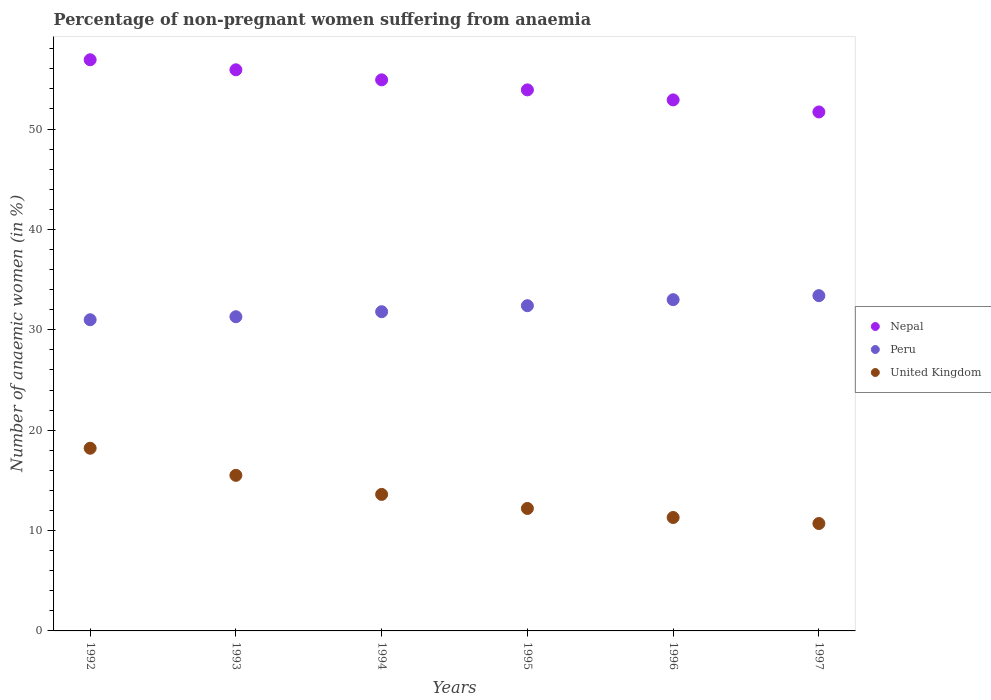What is the percentage of non-pregnant women suffering from anaemia in Peru in 1993?
Provide a short and direct response. 31.3. Across all years, what is the minimum percentage of non-pregnant women suffering from anaemia in Nepal?
Your response must be concise. 51.7. In which year was the percentage of non-pregnant women suffering from anaemia in Nepal minimum?
Offer a terse response. 1997. What is the total percentage of non-pregnant women suffering from anaemia in United Kingdom in the graph?
Your answer should be compact. 81.5. What is the difference between the percentage of non-pregnant women suffering from anaemia in United Kingdom in 1995 and that in 1997?
Your response must be concise. 1.5. What is the difference between the percentage of non-pregnant women suffering from anaemia in Peru in 1994 and the percentage of non-pregnant women suffering from anaemia in Nepal in 1996?
Give a very brief answer. -21.1. What is the average percentage of non-pregnant women suffering from anaemia in Nepal per year?
Ensure brevity in your answer.  54.37. In the year 1993, what is the difference between the percentage of non-pregnant women suffering from anaemia in United Kingdom and percentage of non-pregnant women suffering from anaemia in Nepal?
Your response must be concise. -40.4. What is the ratio of the percentage of non-pregnant women suffering from anaemia in Peru in 1996 to that in 1997?
Keep it short and to the point. 0.99. Is the difference between the percentage of non-pregnant women suffering from anaemia in United Kingdom in 1993 and 1997 greater than the difference between the percentage of non-pregnant women suffering from anaemia in Nepal in 1993 and 1997?
Provide a short and direct response. Yes. What is the difference between the highest and the second highest percentage of non-pregnant women suffering from anaemia in United Kingdom?
Offer a terse response. 2.7. Is the sum of the percentage of non-pregnant women suffering from anaemia in Nepal in 1993 and 1996 greater than the maximum percentage of non-pregnant women suffering from anaemia in United Kingdom across all years?
Provide a succinct answer. Yes. What is the difference between two consecutive major ticks on the Y-axis?
Make the answer very short. 10. Are the values on the major ticks of Y-axis written in scientific E-notation?
Offer a very short reply. No. How many legend labels are there?
Your answer should be very brief. 3. How are the legend labels stacked?
Provide a short and direct response. Vertical. What is the title of the graph?
Ensure brevity in your answer.  Percentage of non-pregnant women suffering from anaemia. What is the label or title of the X-axis?
Give a very brief answer. Years. What is the label or title of the Y-axis?
Keep it short and to the point. Number of anaemic women (in %). What is the Number of anaemic women (in %) in Nepal in 1992?
Give a very brief answer. 56.9. What is the Number of anaemic women (in %) in Nepal in 1993?
Provide a succinct answer. 55.9. What is the Number of anaemic women (in %) in Peru in 1993?
Offer a terse response. 31.3. What is the Number of anaemic women (in %) of Nepal in 1994?
Your answer should be very brief. 54.9. What is the Number of anaemic women (in %) in Peru in 1994?
Ensure brevity in your answer.  31.8. What is the Number of anaemic women (in %) of United Kingdom in 1994?
Your answer should be compact. 13.6. What is the Number of anaemic women (in %) of Nepal in 1995?
Give a very brief answer. 53.9. What is the Number of anaemic women (in %) in Peru in 1995?
Your answer should be compact. 32.4. What is the Number of anaemic women (in %) in Nepal in 1996?
Provide a succinct answer. 52.9. What is the Number of anaemic women (in %) of Nepal in 1997?
Offer a very short reply. 51.7. What is the Number of anaemic women (in %) in Peru in 1997?
Give a very brief answer. 33.4. What is the Number of anaemic women (in %) in United Kingdom in 1997?
Your response must be concise. 10.7. Across all years, what is the maximum Number of anaemic women (in %) in Nepal?
Keep it short and to the point. 56.9. Across all years, what is the maximum Number of anaemic women (in %) of Peru?
Your response must be concise. 33.4. Across all years, what is the maximum Number of anaemic women (in %) in United Kingdom?
Keep it short and to the point. 18.2. Across all years, what is the minimum Number of anaemic women (in %) in Nepal?
Make the answer very short. 51.7. Across all years, what is the minimum Number of anaemic women (in %) of United Kingdom?
Ensure brevity in your answer.  10.7. What is the total Number of anaemic women (in %) in Nepal in the graph?
Ensure brevity in your answer.  326.2. What is the total Number of anaemic women (in %) in Peru in the graph?
Ensure brevity in your answer.  192.9. What is the total Number of anaemic women (in %) in United Kingdom in the graph?
Your response must be concise. 81.5. What is the difference between the Number of anaemic women (in %) of United Kingdom in 1992 and that in 1993?
Keep it short and to the point. 2.7. What is the difference between the Number of anaemic women (in %) in Nepal in 1992 and that in 1994?
Make the answer very short. 2. What is the difference between the Number of anaemic women (in %) of Nepal in 1992 and that in 1995?
Offer a terse response. 3. What is the difference between the Number of anaemic women (in %) of United Kingdom in 1992 and that in 1995?
Make the answer very short. 6. What is the difference between the Number of anaemic women (in %) in Nepal in 1992 and that in 1996?
Your answer should be very brief. 4. What is the difference between the Number of anaemic women (in %) of Peru in 1992 and that in 1996?
Your answer should be very brief. -2. What is the difference between the Number of anaemic women (in %) of United Kingdom in 1992 and that in 1996?
Offer a very short reply. 6.9. What is the difference between the Number of anaemic women (in %) in Nepal in 1992 and that in 1997?
Provide a succinct answer. 5.2. What is the difference between the Number of anaemic women (in %) in Nepal in 1993 and that in 1995?
Offer a terse response. 2. What is the difference between the Number of anaemic women (in %) in United Kingdom in 1993 and that in 1995?
Offer a very short reply. 3.3. What is the difference between the Number of anaemic women (in %) in United Kingdom in 1993 and that in 1996?
Your answer should be very brief. 4.2. What is the difference between the Number of anaemic women (in %) of Nepal in 1993 and that in 1997?
Make the answer very short. 4.2. What is the difference between the Number of anaemic women (in %) of Peru in 1993 and that in 1997?
Offer a terse response. -2.1. What is the difference between the Number of anaemic women (in %) in United Kingdom in 1993 and that in 1997?
Make the answer very short. 4.8. What is the difference between the Number of anaemic women (in %) in Nepal in 1994 and that in 1995?
Keep it short and to the point. 1. What is the difference between the Number of anaemic women (in %) in United Kingdom in 1994 and that in 1995?
Offer a very short reply. 1.4. What is the difference between the Number of anaemic women (in %) of Nepal in 1994 and that in 1996?
Provide a succinct answer. 2. What is the difference between the Number of anaemic women (in %) of Peru in 1994 and that in 1996?
Give a very brief answer. -1.2. What is the difference between the Number of anaemic women (in %) of Peru in 1994 and that in 1997?
Keep it short and to the point. -1.6. What is the difference between the Number of anaemic women (in %) in United Kingdom in 1994 and that in 1997?
Your answer should be compact. 2.9. What is the difference between the Number of anaemic women (in %) of Peru in 1995 and that in 1996?
Ensure brevity in your answer.  -0.6. What is the difference between the Number of anaemic women (in %) of United Kingdom in 1995 and that in 1996?
Offer a very short reply. 0.9. What is the difference between the Number of anaemic women (in %) in Nepal in 1995 and that in 1997?
Offer a very short reply. 2.2. What is the difference between the Number of anaemic women (in %) of Peru in 1995 and that in 1997?
Give a very brief answer. -1. What is the difference between the Number of anaemic women (in %) of Nepal in 1992 and the Number of anaemic women (in %) of Peru in 1993?
Offer a very short reply. 25.6. What is the difference between the Number of anaemic women (in %) of Nepal in 1992 and the Number of anaemic women (in %) of United Kingdom in 1993?
Offer a very short reply. 41.4. What is the difference between the Number of anaemic women (in %) of Peru in 1992 and the Number of anaemic women (in %) of United Kingdom in 1993?
Keep it short and to the point. 15.5. What is the difference between the Number of anaemic women (in %) in Nepal in 1992 and the Number of anaemic women (in %) in Peru in 1994?
Your answer should be compact. 25.1. What is the difference between the Number of anaemic women (in %) of Nepal in 1992 and the Number of anaemic women (in %) of United Kingdom in 1994?
Offer a terse response. 43.3. What is the difference between the Number of anaemic women (in %) of Peru in 1992 and the Number of anaemic women (in %) of United Kingdom in 1994?
Provide a succinct answer. 17.4. What is the difference between the Number of anaemic women (in %) in Nepal in 1992 and the Number of anaemic women (in %) in Peru in 1995?
Offer a very short reply. 24.5. What is the difference between the Number of anaemic women (in %) in Nepal in 1992 and the Number of anaemic women (in %) in United Kingdom in 1995?
Your answer should be very brief. 44.7. What is the difference between the Number of anaemic women (in %) in Nepal in 1992 and the Number of anaemic women (in %) in Peru in 1996?
Your answer should be compact. 23.9. What is the difference between the Number of anaemic women (in %) of Nepal in 1992 and the Number of anaemic women (in %) of United Kingdom in 1996?
Your answer should be very brief. 45.6. What is the difference between the Number of anaemic women (in %) in Nepal in 1992 and the Number of anaemic women (in %) in United Kingdom in 1997?
Keep it short and to the point. 46.2. What is the difference between the Number of anaemic women (in %) in Peru in 1992 and the Number of anaemic women (in %) in United Kingdom in 1997?
Offer a terse response. 20.3. What is the difference between the Number of anaemic women (in %) of Nepal in 1993 and the Number of anaemic women (in %) of Peru in 1994?
Make the answer very short. 24.1. What is the difference between the Number of anaemic women (in %) of Nepal in 1993 and the Number of anaemic women (in %) of United Kingdom in 1994?
Offer a terse response. 42.3. What is the difference between the Number of anaemic women (in %) in Peru in 1993 and the Number of anaemic women (in %) in United Kingdom in 1994?
Provide a succinct answer. 17.7. What is the difference between the Number of anaemic women (in %) of Nepal in 1993 and the Number of anaemic women (in %) of Peru in 1995?
Your answer should be compact. 23.5. What is the difference between the Number of anaemic women (in %) of Nepal in 1993 and the Number of anaemic women (in %) of United Kingdom in 1995?
Make the answer very short. 43.7. What is the difference between the Number of anaemic women (in %) in Peru in 1993 and the Number of anaemic women (in %) in United Kingdom in 1995?
Make the answer very short. 19.1. What is the difference between the Number of anaemic women (in %) of Nepal in 1993 and the Number of anaemic women (in %) of Peru in 1996?
Provide a short and direct response. 22.9. What is the difference between the Number of anaemic women (in %) of Nepal in 1993 and the Number of anaemic women (in %) of United Kingdom in 1996?
Your response must be concise. 44.6. What is the difference between the Number of anaemic women (in %) of Nepal in 1993 and the Number of anaemic women (in %) of Peru in 1997?
Offer a terse response. 22.5. What is the difference between the Number of anaemic women (in %) in Nepal in 1993 and the Number of anaemic women (in %) in United Kingdom in 1997?
Your answer should be very brief. 45.2. What is the difference between the Number of anaemic women (in %) in Peru in 1993 and the Number of anaemic women (in %) in United Kingdom in 1997?
Provide a short and direct response. 20.6. What is the difference between the Number of anaemic women (in %) of Nepal in 1994 and the Number of anaemic women (in %) of Peru in 1995?
Your response must be concise. 22.5. What is the difference between the Number of anaemic women (in %) of Nepal in 1994 and the Number of anaemic women (in %) of United Kingdom in 1995?
Your answer should be compact. 42.7. What is the difference between the Number of anaemic women (in %) of Peru in 1994 and the Number of anaemic women (in %) of United Kingdom in 1995?
Your answer should be compact. 19.6. What is the difference between the Number of anaemic women (in %) of Nepal in 1994 and the Number of anaemic women (in %) of Peru in 1996?
Your answer should be very brief. 21.9. What is the difference between the Number of anaemic women (in %) in Nepal in 1994 and the Number of anaemic women (in %) in United Kingdom in 1996?
Provide a short and direct response. 43.6. What is the difference between the Number of anaemic women (in %) in Nepal in 1994 and the Number of anaemic women (in %) in United Kingdom in 1997?
Provide a short and direct response. 44.2. What is the difference between the Number of anaemic women (in %) in Peru in 1994 and the Number of anaemic women (in %) in United Kingdom in 1997?
Provide a succinct answer. 21.1. What is the difference between the Number of anaemic women (in %) in Nepal in 1995 and the Number of anaemic women (in %) in Peru in 1996?
Keep it short and to the point. 20.9. What is the difference between the Number of anaemic women (in %) of Nepal in 1995 and the Number of anaemic women (in %) of United Kingdom in 1996?
Offer a very short reply. 42.6. What is the difference between the Number of anaemic women (in %) in Peru in 1995 and the Number of anaemic women (in %) in United Kingdom in 1996?
Your answer should be compact. 21.1. What is the difference between the Number of anaemic women (in %) in Nepal in 1995 and the Number of anaemic women (in %) in Peru in 1997?
Make the answer very short. 20.5. What is the difference between the Number of anaemic women (in %) in Nepal in 1995 and the Number of anaemic women (in %) in United Kingdom in 1997?
Provide a short and direct response. 43.2. What is the difference between the Number of anaemic women (in %) of Peru in 1995 and the Number of anaemic women (in %) of United Kingdom in 1997?
Provide a succinct answer. 21.7. What is the difference between the Number of anaemic women (in %) of Nepal in 1996 and the Number of anaemic women (in %) of Peru in 1997?
Offer a very short reply. 19.5. What is the difference between the Number of anaemic women (in %) in Nepal in 1996 and the Number of anaemic women (in %) in United Kingdom in 1997?
Give a very brief answer. 42.2. What is the difference between the Number of anaemic women (in %) of Peru in 1996 and the Number of anaemic women (in %) of United Kingdom in 1997?
Offer a very short reply. 22.3. What is the average Number of anaemic women (in %) in Nepal per year?
Ensure brevity in your answer.  54.37. What is the average Number of anaemic women (in %) of Peru per year?
Your answer should be very brief. 32.15. What is the average Number of anaemic women (in %) of United Kingdom per year?
Your answer should be very brief. 13.58. In the year 1992, what is the difference between the Number of anaemic women (in %) of Nepal and Number of anaemic women (in %) of Peru?
Offer a terse response. 25.9. In the year 1992, what is the difference between the Number of anaemic women (in %) of Nepal and Number of anaemic women (in %) of United Kingdom?
Provide a succinct answer. 38.7. In the year 1993, what is the difference between the Number of anaemic women (in %) in Nepal and Number of anaemic women (in %) in Peru?
Your answer should be very brief. 24.6. In the year 1993, what is the difference between the Number of anaemic women (in %) in Nepal and Number of anaemic women (in %) in United Kingdom?
Your answer should be very brief. 40.4. In the year 1993, what is the difference between the Number of anaemic women (in %) in Peru and Number of anaemic women (in %) in United Kingdom?
Your answer should be compact. 15.8. In the year 1994, what is the difference between the Number of anaemic women (in %) in Nepal and Number of anaemic women (in %) in Peru?
Your answer should be compact. 23.1. In the year 1994, what is the difference between the Number of anaemic women (in %) of Nepal and Number of anaemic women (in %) of United Kingdom?
Offer a terse response. 41.3. In the year 1995, what is the difference between the Number of anaemic women (in %) of Nepal and Number of anaemic women (in %) of Peru?
Ensure brevity in your answer.  21.5. In the year 1995, what is the difference between the Number of anaemic women (in %) of Nepal and Number of anaemic women (in %) of United Kingdom?
Ensure brevity in your answer.  41.7. In the year 1995, what is the difference between the Number of anaemic women (in %) in Peru and Number of anaemic women (in %) in United Kingdom?
Make the answer very short. 20.2. In the year 1996, what is the difference between the Number of anaemic women (in %) in Nepal and Number of anaemic women (in %) in Peru?
Your answer should be very brief. 19.9. In the year 1996, what is the difference between the Number of anaemic women (in %) of Nepal and Number of anaemic women (in %) of United Kingdom?
Keep it short and to the point. 41.6. In the year 1996, what is the difference between the Number of anaemic women (in %) of Peru and Number of anaemic women (in %) of United Kingdom?
Offer a terse response. 21.7. In the year 1997, what is the difference between the Number of anaemic women (in %) of Nepal and Number of anaemic women (in %) of United Kingdom?
Offer a very short reply. 41. In the year 1997, what is the difference between the Number of anaemic women (in %) in Peru and Number of anaemic women (in %) in United Kingdom?
Ensure brevity in your answer.  22.7. What is the ratio of the Number of anaemic women (in %) in Nepal in 1992 to that in 1993?
Make the answer very short. 1.02. What is the ratio of the Number of anaemic women (in %) in Peru in 1992 to that in 1993?
Make the answer very short. 0.99. What is the ratio of the Number of anaemic women (in %) in United Kingdom in 1992 to that in 1993?
Offer a very short reply. 1.17. What is the ratio of the Number of anaemic women (in %) of Nepal in 1992 to that in 1994?
Give a very brief answer. 1.04. What is the ratio of the Number of anaemic women (in %) of Peru in 1992 to that in 1994?
Your answer should be very brief. 0.97. What is the ratio of the Number of anaemic women (in %) of United Kingdom in 1992 to that in 1994?
Offer a terse response. 1.34. What is the ratio of the Number of anaemic women (in %) of Nepal in 1992 to that in 1995?
Ensure brevity in your answer.  1.06. What is the ratio of the Number of anaemic women (in %) of Peru in 1992 to that in 1995?
Make the answer very short. 0.96. What is the ratio of the Number of anaemic women (in %) of United Kingdom in 1992 to that in 1995?
Ensure brevity in your answer.  1.49. What is the ratio of the Number of anaemic women (in %) of Nepal in 1992 to that in 1996?
Offer a very short reply. 1.08. What is the ratio of the Number of anaemic women (in %) in Peru in 1992 to that in 1996?
Keep it short and to the point. 0.94. What is the ratio of the Number of anaemic women (in %) in United Kingdom in 1992 to that in 1996?
Your response must be concise. 1.61. What is the ratio of the Number of anaemic women (in %) in Nepal in 1992 to that in 1997?
Your response must be concise. 1.1. What is the ratio of the Number of anaemic women (in %) of Peru in 1992 to that in 1997?
Keep it short and to the point. 0.93. What is the ratio of the Number of anaemic women (in %) in United Kingdom in 1992 to that in 1997?
Your answer should be very brief. 1.7. What is the ratio of the Number of anaemic women (in %) of Nepal in 1993 to that in 1994?
Offer a very short reply. 1.02. What is the ratio of the Number of anaemic women (in %) of Peru in 1993 to that in 1994?
Keep it short and to the point. 0.98. What is the ratio of the Number of anaemic women (in %) of United Kingdom in 1993 to that in 1994?
Your answer should be compact. 1.14. What is the ratio of the Number of anaemic women (in %) of Nepal in 1993 to that in 1995?
Give a very brief answer. 1.04. What is the ratio of the Number of anaemic women (in %) in Peru in 1993 to that in 1995?
Keep it short and to the point. 0.97. What is the ratio of the Number of anaemic women (in %) of United Kingdom in 1993 to that in 1995?
Your answer should be very brief. 1.27. What is the ratio of the Number of anaemic women (in %) of Nepal in 1993 to that in 1996?
Your response must be concise. 1.06. What is the ratio of the Number of anaemic women (in %) in Peru in 1993 to that in 1996?
Provide a short and direct response. 0.95. What is the ratio of the Number of anaemic women (in %) of United Kingdom in 1993 to that in 1996?
Offer a terse response. 1.37. What is the ratio of the Number of anaemic women (in %) of Nepal in 1993 to that in 1997?
Keep it short and to the point. 1.08. What is the ratio of the Number of anaemic women (in %) of Peru in 1993 to that in 1997?
Ensure brevity in your answer.  0.94. What is the ratio of the Number of anaemic women (in %) of United Kingdom in 1993 to that in 1997?
Your answer should be compact. 1.45. What is the ratio of the Number of anaemic women (in %) in Nepal in 1994 to that in 1995?
Your response must be concise. 1.02. What is the ratio of the Number of anaemic women (in %) in Peru in 1994 to that in 1995?
Provide a succinct answer. 0.98. What is the ratio of the Number of anaemic women (in %) of United Kingdom in 1994 to that in 1995?
Offer a terse response. 1.11. What is the ratio of the Number of anaemic women (in %) of Nepal in 1994 to that in 1996?
Make the answer very short. 1.04. What is the ratio of the Number of anaemic women (in %) in Peru in 1994 to that in 1996?
Provide a short and direct response. 0.96. What is the ratio of the Number of anaemic women (in %) of United Kingdom in 1994 to that in 1996?
Ensure brevity in your answer.  1.2. What is the ratio of the Number of anaemic women (in %) of Nepal in 1994 to that in 1997?
Your answer should be compact. 1.06. What is the ratio of the Number of anaemic women (in %) of Peru in 1994 to that in 1997?
Offer a terse response. 0.95. What is the ratio of the Number of anaemic women (in %) of United Kingdom in 1994 to that in 1997?
Make the answer very short. 1.27. What is the ratio of the Number of anaemic women (in %) in Nepal in 1995 to that in 1996?
Provide a short and direct response. 1.02. What is the ratio of the Number of anaemic women (in %) in Peru in 1995 to that in 1996?
Provide a succinct answer. 0.98. What is the ratio of the Number of anaemic women (in %) of United Kingdom in 1995 to that in 1996?
Make the answer very short. 1.08. What is the ratio of the Number of anaemic women (in %) in Nepal in 1995 to that in 1997?
Offer a very short reply. 1.04. What is the ratio of the Number of anaemic women (in %) in Peru in 1995 to that in 1997?
Make the answer very short. 0.97. What is the ratio of the Number of anaemic women (in %) in United Kingdom in 1995 to that in 1997?
Your answer should be compact. 1.14. What is the ratio of the Number of anaemic women (in %) of Nepal in 1996 to that in 1997?
Provide a short and direct response. 1.02. What is the ratio of the Number of anaemic women (in %) of Peru in 1996 to that in 1997?
Offer a very short reply. 0.99. What is the ratio of the Number of anaemic women (in %) in United Kingdom in 1996 to that in 1997?
Ensure brevity in your answer.  1.06. What is the difference between the highest and the second highest Number of anaemic women (in %) of United Kingdom?
Your answer should be compact. 2.7. What is the difference between the highest and the lowest Number of anaemic women (in %) of Nepal?
Make the answer very short. 5.2. What is the difference between the highest and the lowest Number of anaemic women (in %) in Peru?
Provide a short and direct response. 2.4. What is the difference between the highest and the lowest Number of anaemic women (in %) of United Kingdom?
Keep it short and to the point. 7.5. 